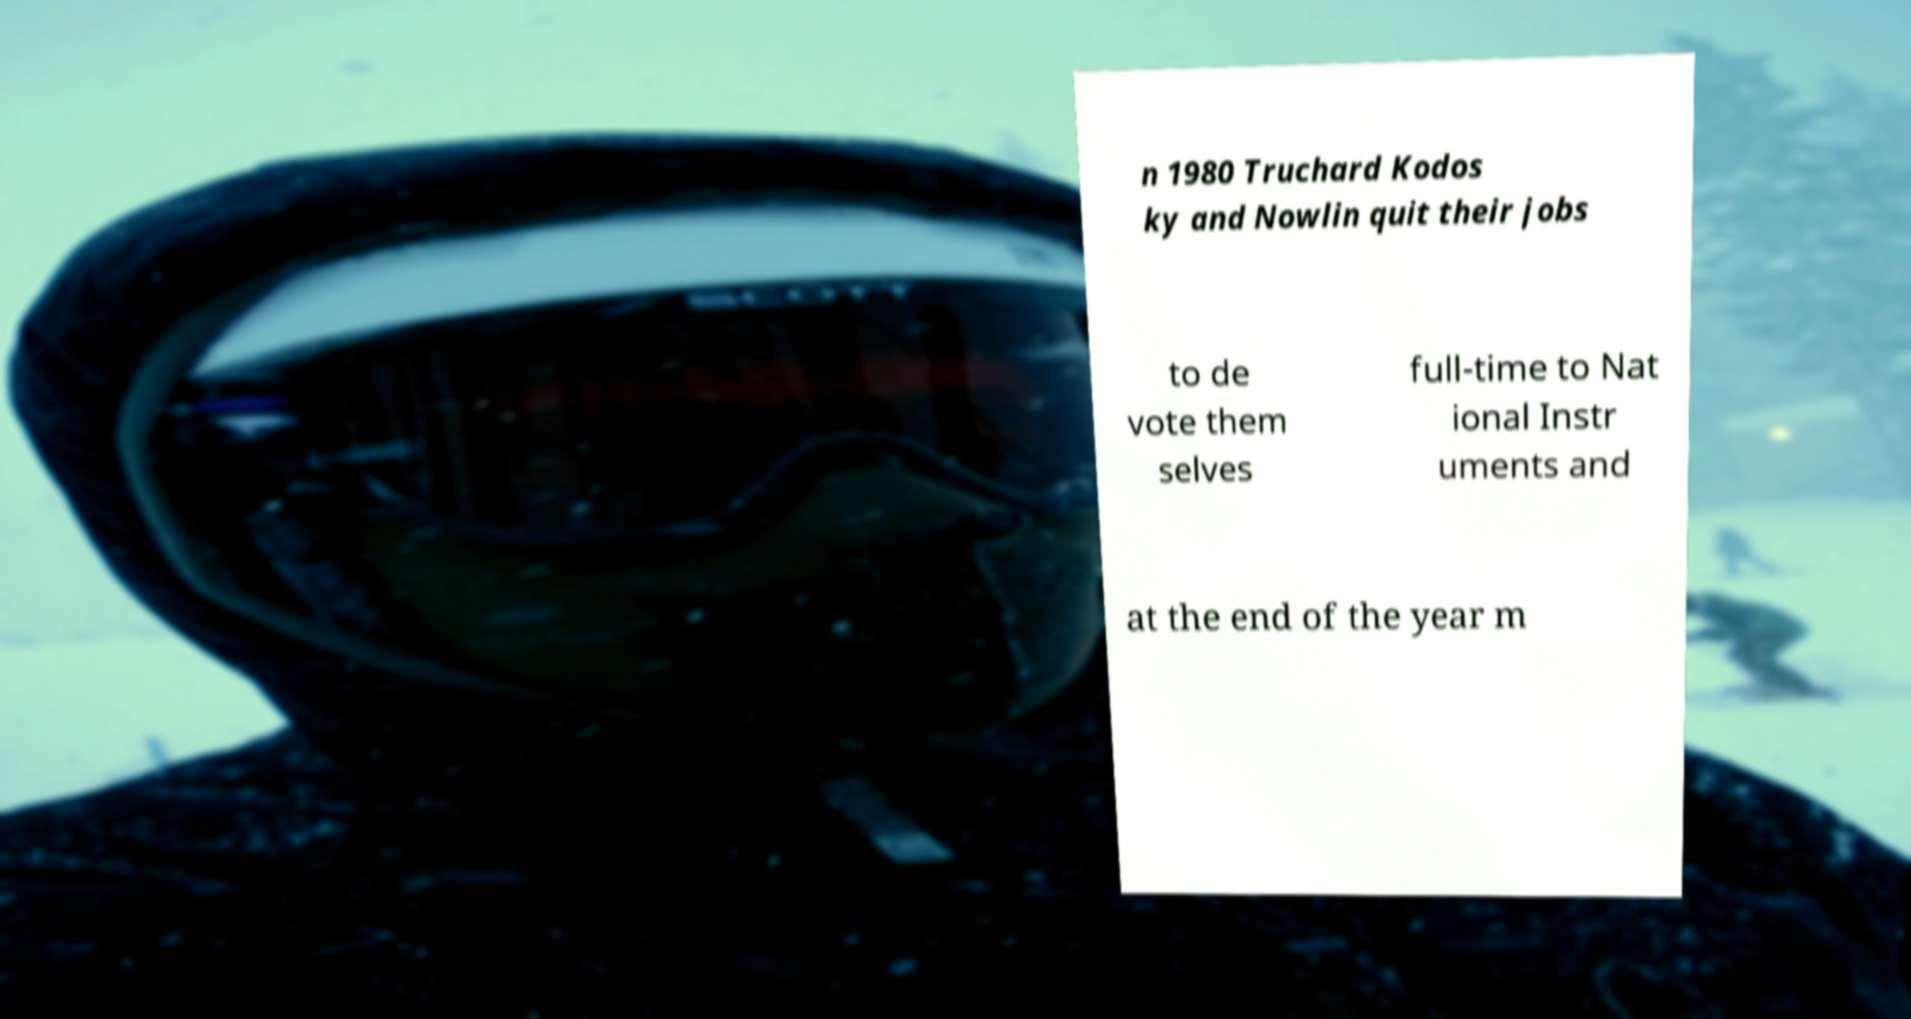Can you accurately transcribe the text from the provided image for me? n 1980 Truchard Kodos ky and Nowlin quit their jobs to de vote them selves full-time to Nat ional Instr uments and at the end of the year m 